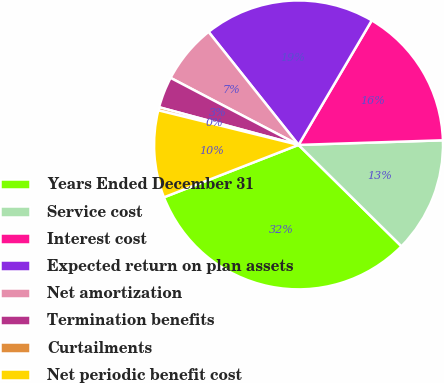<chart> <loc_0><loc_0><loc_500><loc_500><pie_chart><fcel>Years Ended December 31<fcel>Service cost<fcel>Interest cost<fcel>Expected return on plan assets<fcel>Net amortization<fcel>Termination benefits<fcel>Curtailments<fcel>Net periodic benefit cost<nl><fcel>31.71%<fcel>12.89%<fcel>16.03%<fcel>19.16%<fcel>6.62%<fcel>3.48%<fcel>0.35%<fcel>9.76%<nl></chart> 